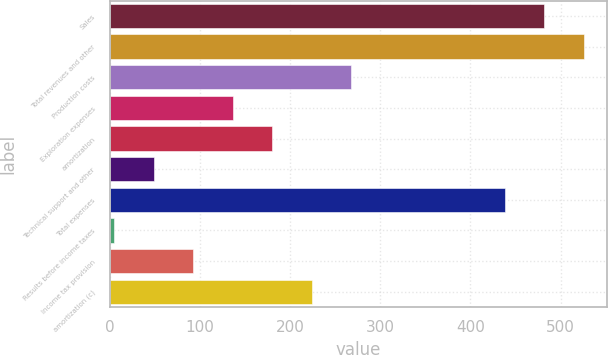Convert chart. <chart><loc_0><loc_0><loc_500><loc_500><bar_chart><fcel>Sales<fcel>Total revenues and other<fcel>Production costs<fcel>Exploration expenses<fcel>amortization<fcel>Technical support and other<fcel>Total expenses<fcel>Results before income taxes<fcel>Income tax provision<fcel>amortization (c)<nl><fcel>481.8<fcel>525.6<fcel>267.8<fcel>136.4<fcel>180.2<fcel>48.8<fcel>438<fcel>5<fcel>92.6<fcel>224<nl></chart> 